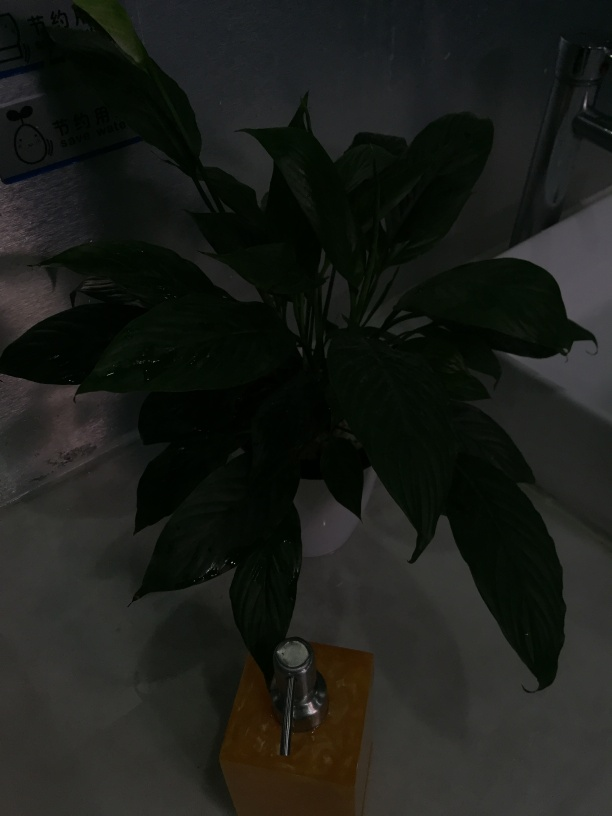What type of plant is this and what care does it need? While the image is dark, the plant appears to have broad leaves, which suggests it could be a peace lily or a similar variety. Such plants typically require indirect sunlight, consistent watering to keep the soil moist, and a warm environment to thrive. Are there any notable characteristics visible in this image that can be used to identify the plant with more certainty? Regretfully, due to the low light and resolution of the image, specific identifying characteristics such as the leaf shape, texture, and vein patterns, which are essential for precise identification, are not clearly visible. 